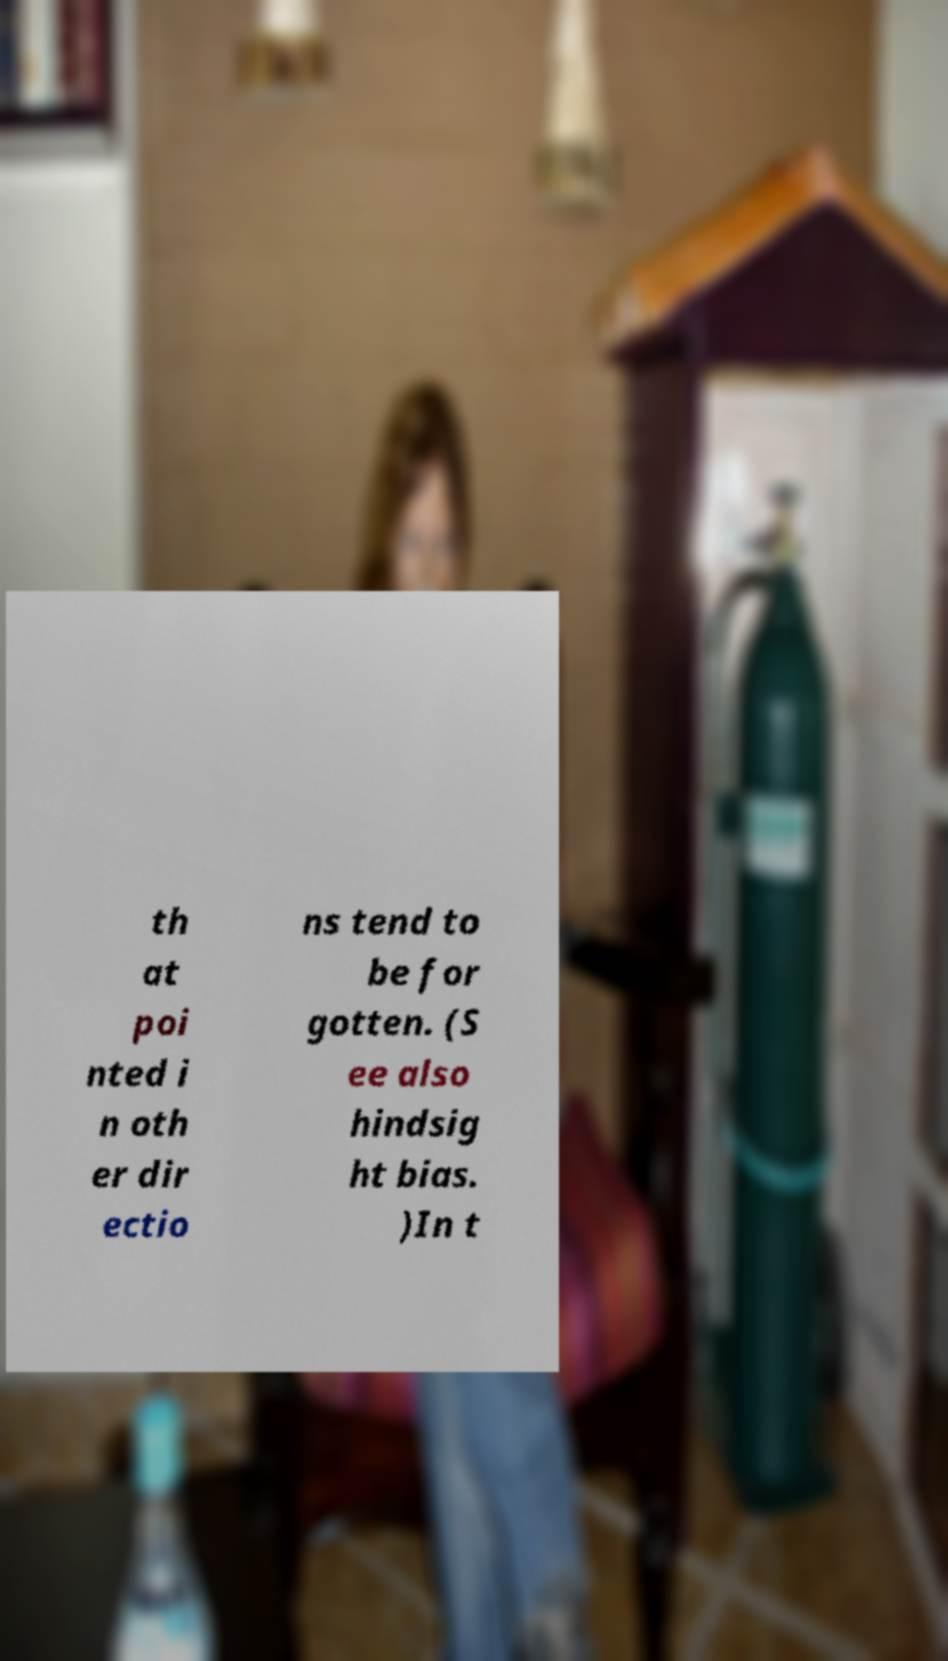Can you read and provide the text displayed in the image?This photo seems to have some interesting text. Can you extract and type it out for me? th at poi nted i n oth er dir ectio ns tend to be for gotten. (S ee also hindsig ht bias. )In t 